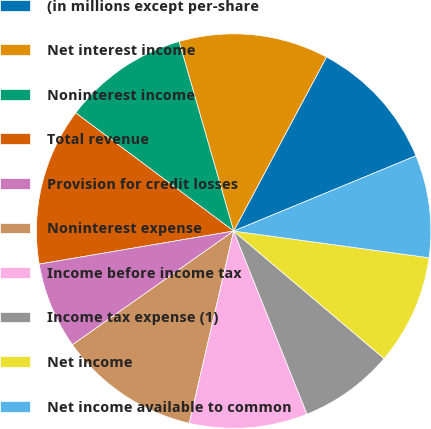<chart> <loc_0><loc_0><loc_500><loc_500><pie_chart><fcel>(in millions except per-share<fcel>Net interest income<fcel>Noninterest income<fcel>Total revenue<fcel>Provision for credit losses<fcel>Noninterest expense<fcel>Income before income tax<fcel>Income tax expense (1)<fcel>Net income<fcel>Net income available to common<nl><fcel>10.97%<fcel>12.26%<fcel>10.32%<fcel>12.9%<fcel>7.1%<fcel>11.61%<fcel>9.68%<fcel>7.74%<fcel>9.03%<fcel>8.39%<nl></chart> 